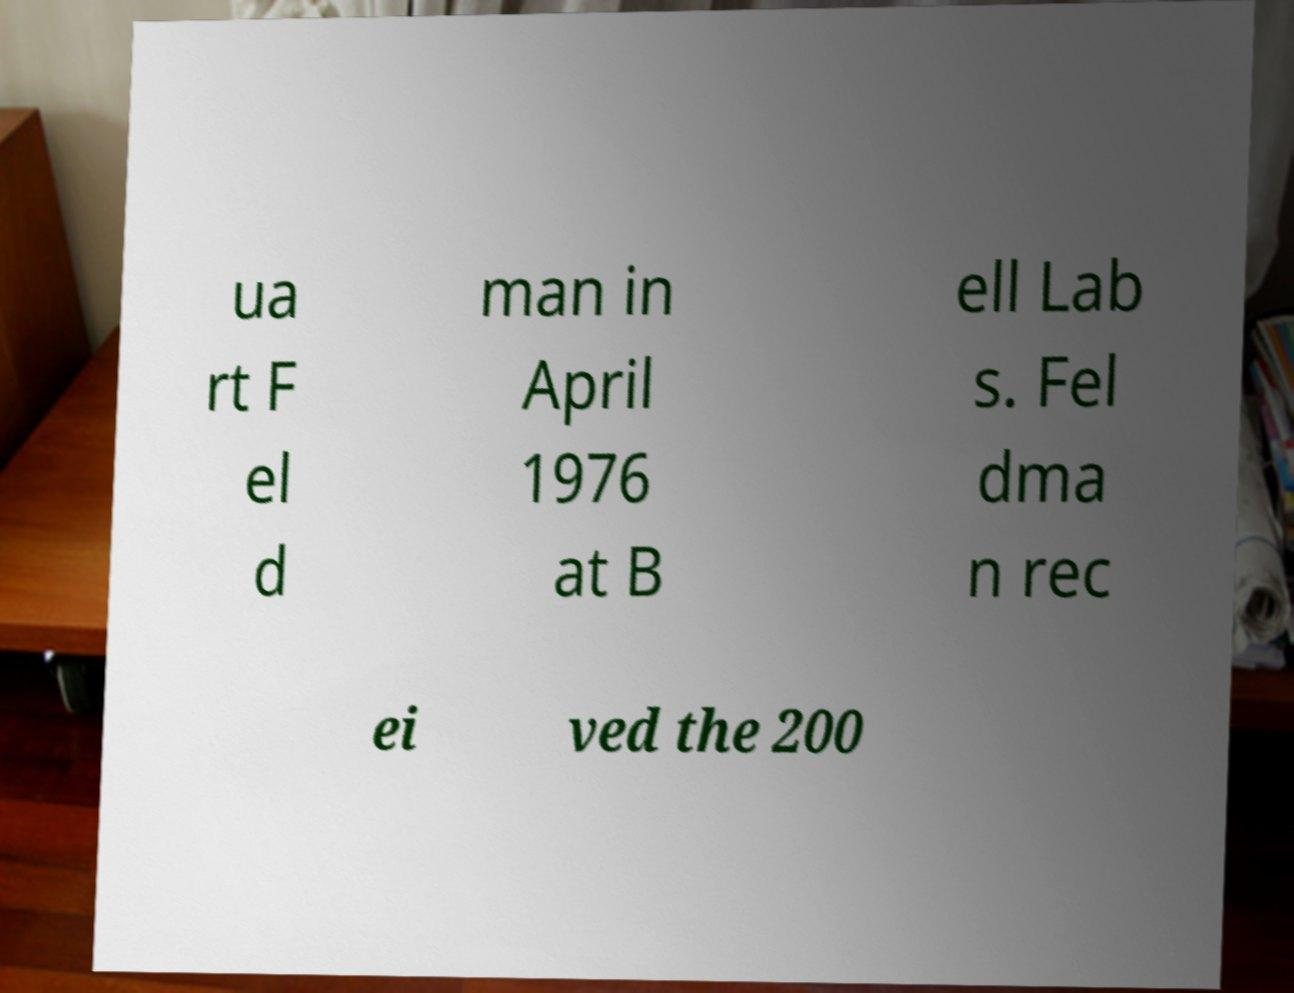Could you extract and type out the text from this image? ua rt F el d man in April 1976 at B ell Lab s. Fel dma n rec ei ved the 200 